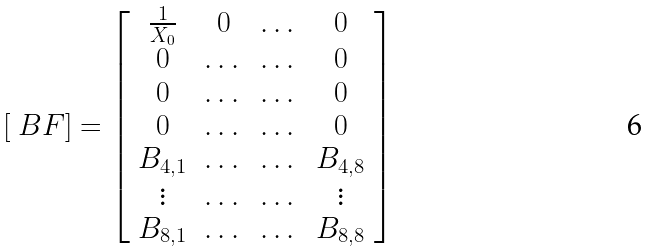Convert formula to latex. <formula><loc_0><loc_0><loc_500><loc_500>[ \ B F ] & = \left [ \begin{array} { c c c c } \frac { 1 } { X _ { 0 } } & 0 & \dots & 0 \\ 0 & \dots & \dots & 0 \\ 0 & \dots & \dots & 0 \\ 0 & \dots & \dots & 0 \\ B _ { 4 , 1 } & \dots & \dots & B _ { 4 , 8 } \\ \vdots & \dots & \dots & \vdots \\ B _ { 8 , 1 } & \dots & \dots & B _ { 8 , 8 } \end{array} \right ]</formula> 